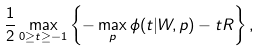Convert formula to latex. <formula><loc_0><loc_0><loc_500><loc_500>\frac { 1 } { 2 } \max _ { 0 \geq t \geq - 1 } \left \{ - \max _ { p } \phi ( t | W , p ) - t R \right \} ,</formula> 